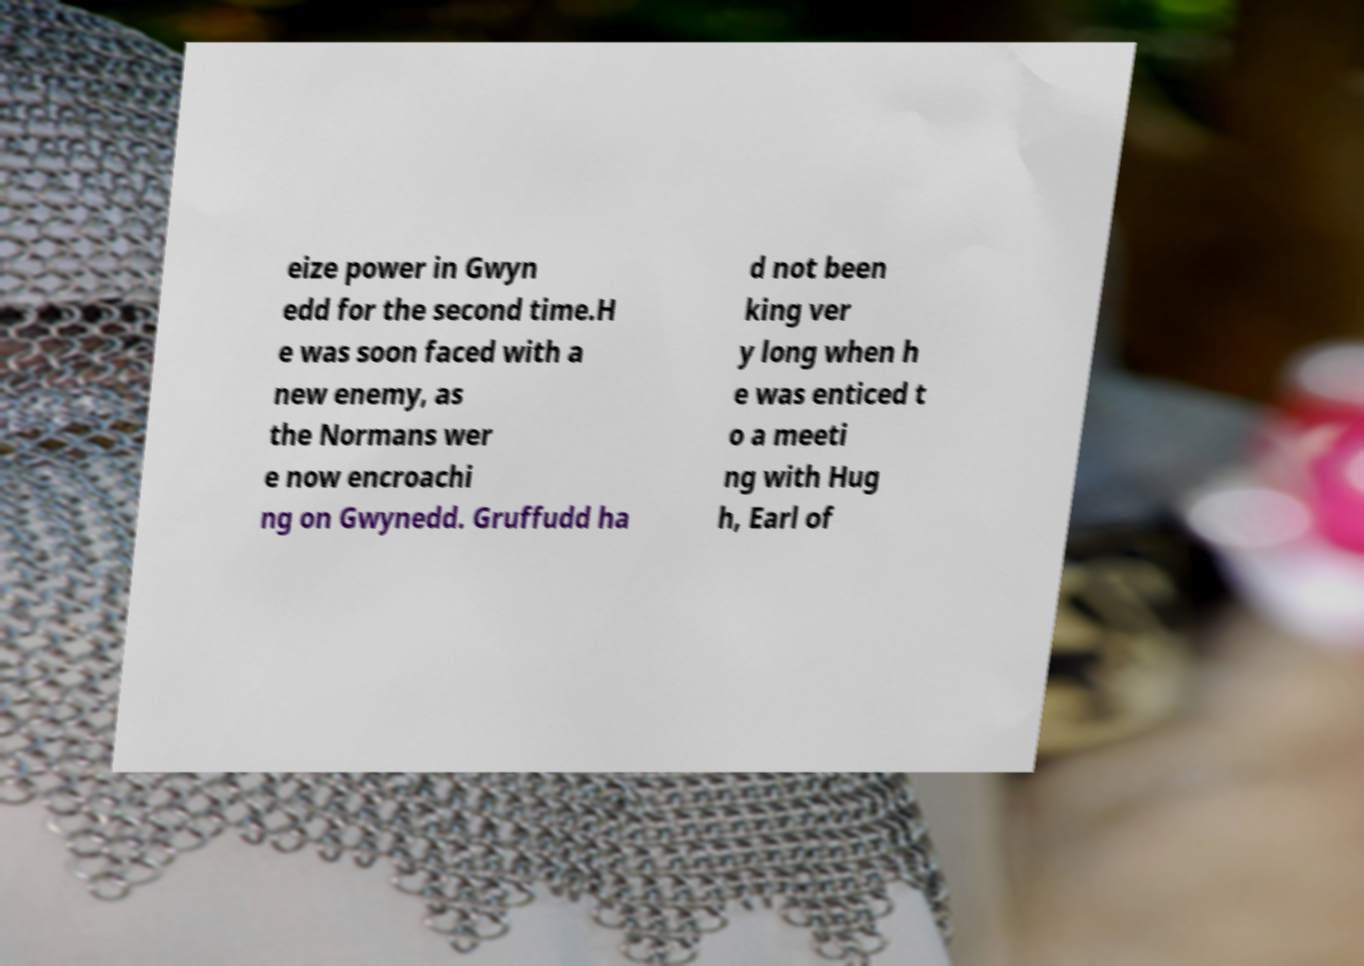There's text embedded in this image that I need extracted. Can you transcribe it verbatim? eize power in Gwyn edd for the second time.H e was soon faced with a new enemy, as the Normans wer e now encroachi ng on Gwynedd. Gruffudd ha d not been king ver y long when h e was enticed t o a meeti ng with Hug h, Earl of 